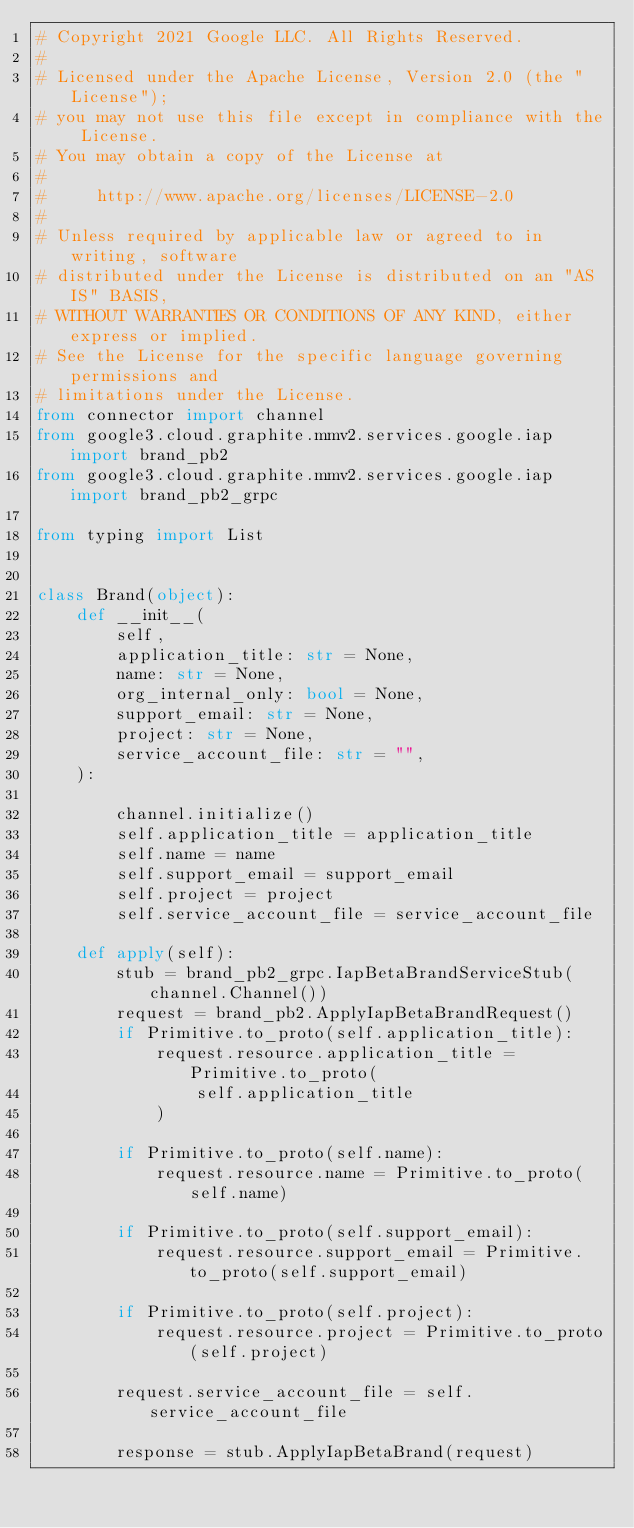Convert code to text. <code><loc_0><loc_0><loc_500><loc_500><_Python_># Copyright 2021 Google LLC. All Rights Reserved.
# 
# Licensed under the Apache License, Version 2.0 (the "License");
# you may not use this file except in compliance with the License.
# You may obtain a copy of the License at
# 
#     http://www.apache.org/licenses/LICENSE-2.0
# 
# Unless required by applicable law or agreed to in writing, software
# distributed under the License is distributed on an "AS IS" BASIS,
# WITHOUT WARRANTIES OR CONDITIONS OF ANY KIND, either express or implied.
# See the License for the specific language governing permissions and
# limitations under the License.
from connector import channel
from google3.cloud.graphite.mmv2.services.google.iap import brand_pb2
from google3.cloud.graphite.mmv2.services.google.iap import brand_pb2_grpc

from typing import List


class Brand(object):
    def __init__(
        self,
        application_title: str = None,
        name: str = None,
        org_internal_only: bool = None,
        support_email: str = None,
        project: str = None,
        service_account_file: str = "",
    ):

        channel.initialize()
        self.application_title = application_title
        self.name = name
        self.support_email = support_email
        self.project = project
        self.service_account_file = service_account_file

    def apply(self):
        stub = brand_pb2_grpc.IapBetaBrandServiceStub(channel.Channel())
        request = brand_pb2.ApplyIapBetaBrandRequest()
        if Primitive.to_proto(self.application_title):
            request.resource.application_title = Primitive.to_proto(
                self.application_title
            )

        if Primitive.to_proto(self.name):
            request.resource.name = Primitive.to_proto(self.name)

        if Primitive.to_proto(self.support_email):
            request.resource.support_email = Primitive.to_proto(self.support_email)

        if Primitive.to_proto(self.project):
            request.resource.project = Primitive.to_proto(self.project)

        request.service_account_file = self.service_account_file

        response = stub.ApplyIapBetaBrand(request)</code> 